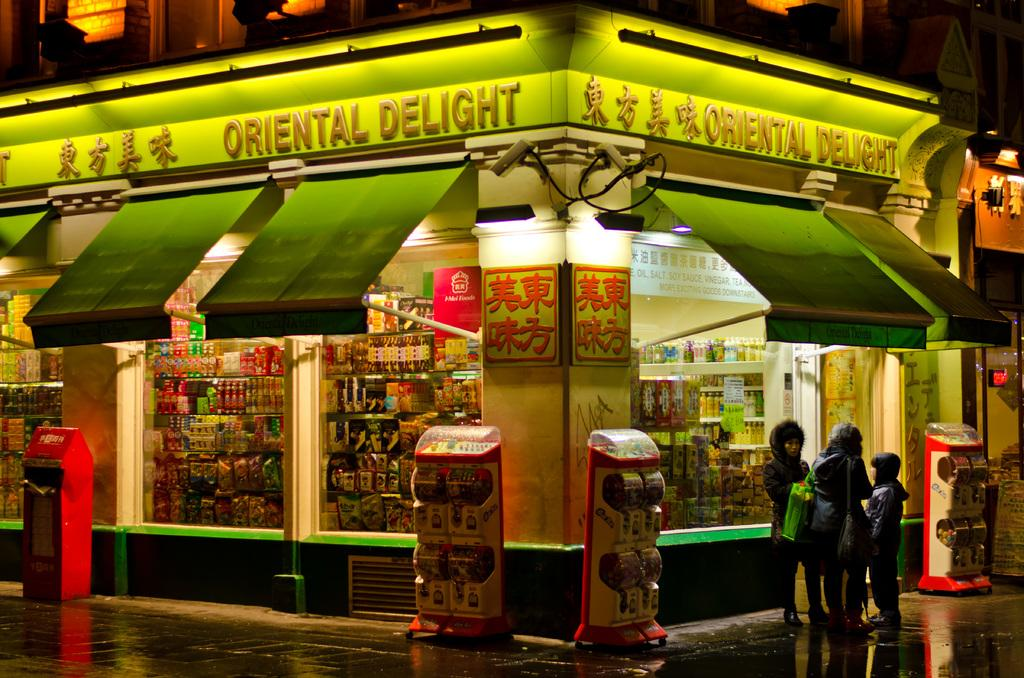<image>
Offer a succinct explanation of the picture presented. A corner store with the name of "Oriental Delight". 